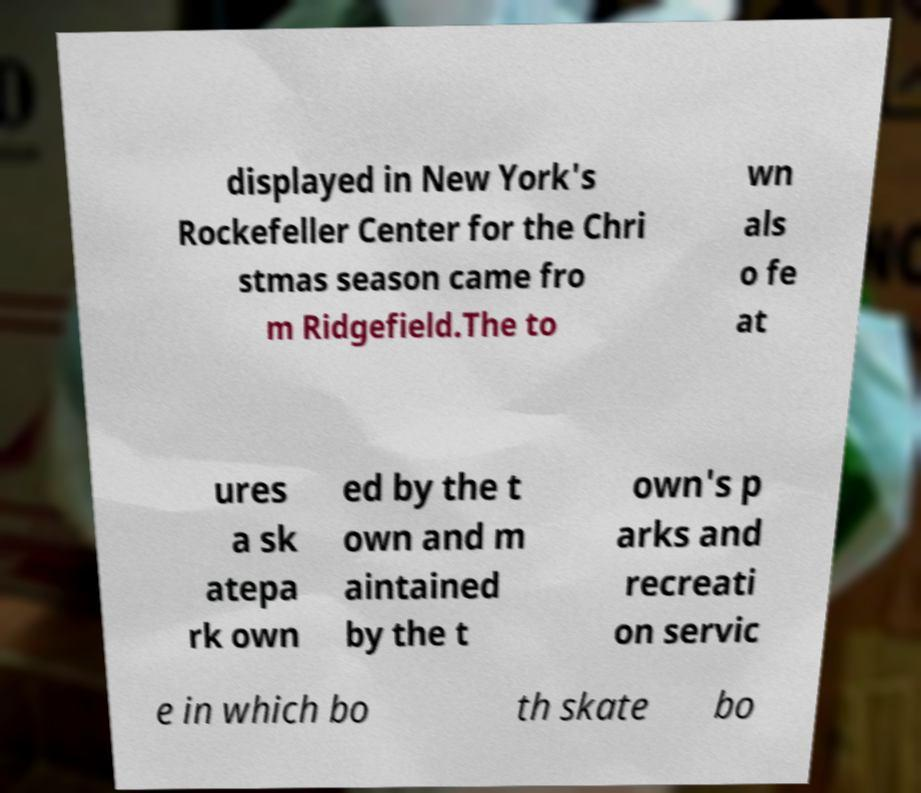What messages or text are displayed in this image? I need them in a readable, typed format. displayed in New York's Rockefeller Center for the Chri stmas season came fro m Ridgefield.The to wn als o fe at ures a sk atepa rk own ed by the t own and m aintained by the t own's p arks and recreati on servic e in which bo th skate bo 